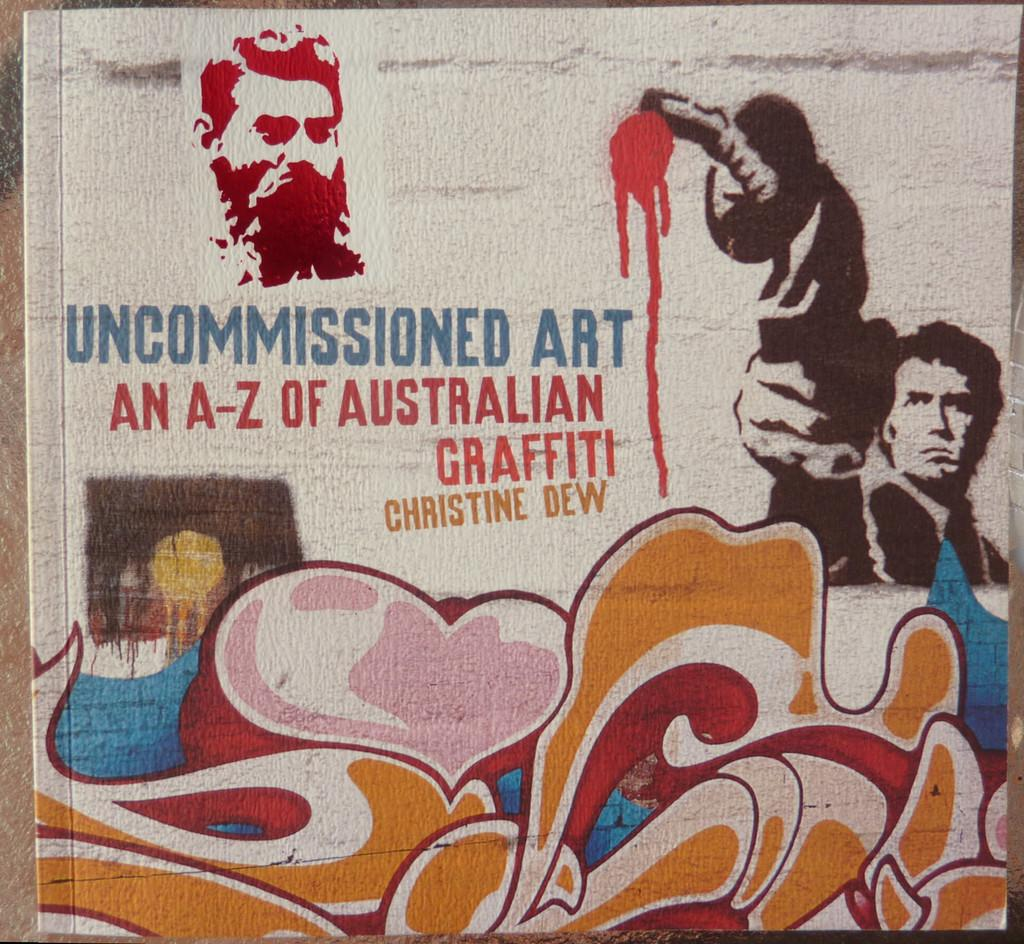What is on the wall in the image? There is a painting, writing, and graffiti on the wall in the image. Can you describe the painting on the wall? Unfortunately, the facts provided do not give any details about the painting. What does the writing on the wall say? The facts provided do not give any information about the content of the writing. What is the subject matter of the graffiti on the wall? The facts provided do not give any details about the graffiti. How many trucks are parked next to the wall in the image? There are no trucks visible in the image; it only shows a wall with a painting, writing, and graffiti. 